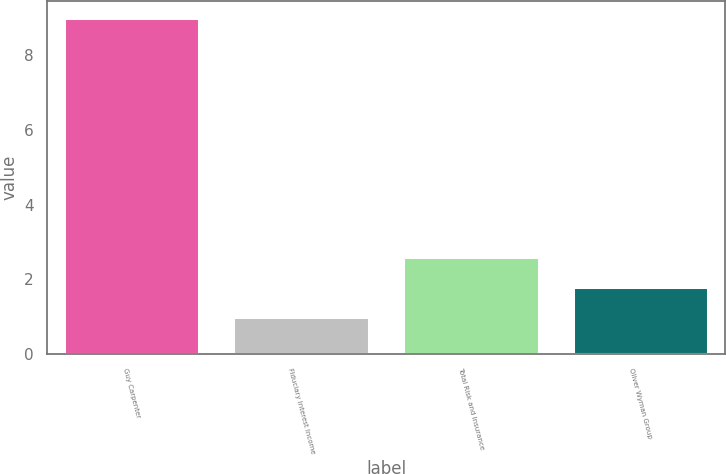<chart> <loc_0><loc_0><loc_500><loc_500><bar_chart><fcel>Guy Carpenter<fcel>Fiduciary Interest Income<fcel>Total Risk and Insurance<fcel>Oliver Wyman Group<nl><fcel>9<fcel>1<fcel>2.6<fcel>1.8<nl></chart> 